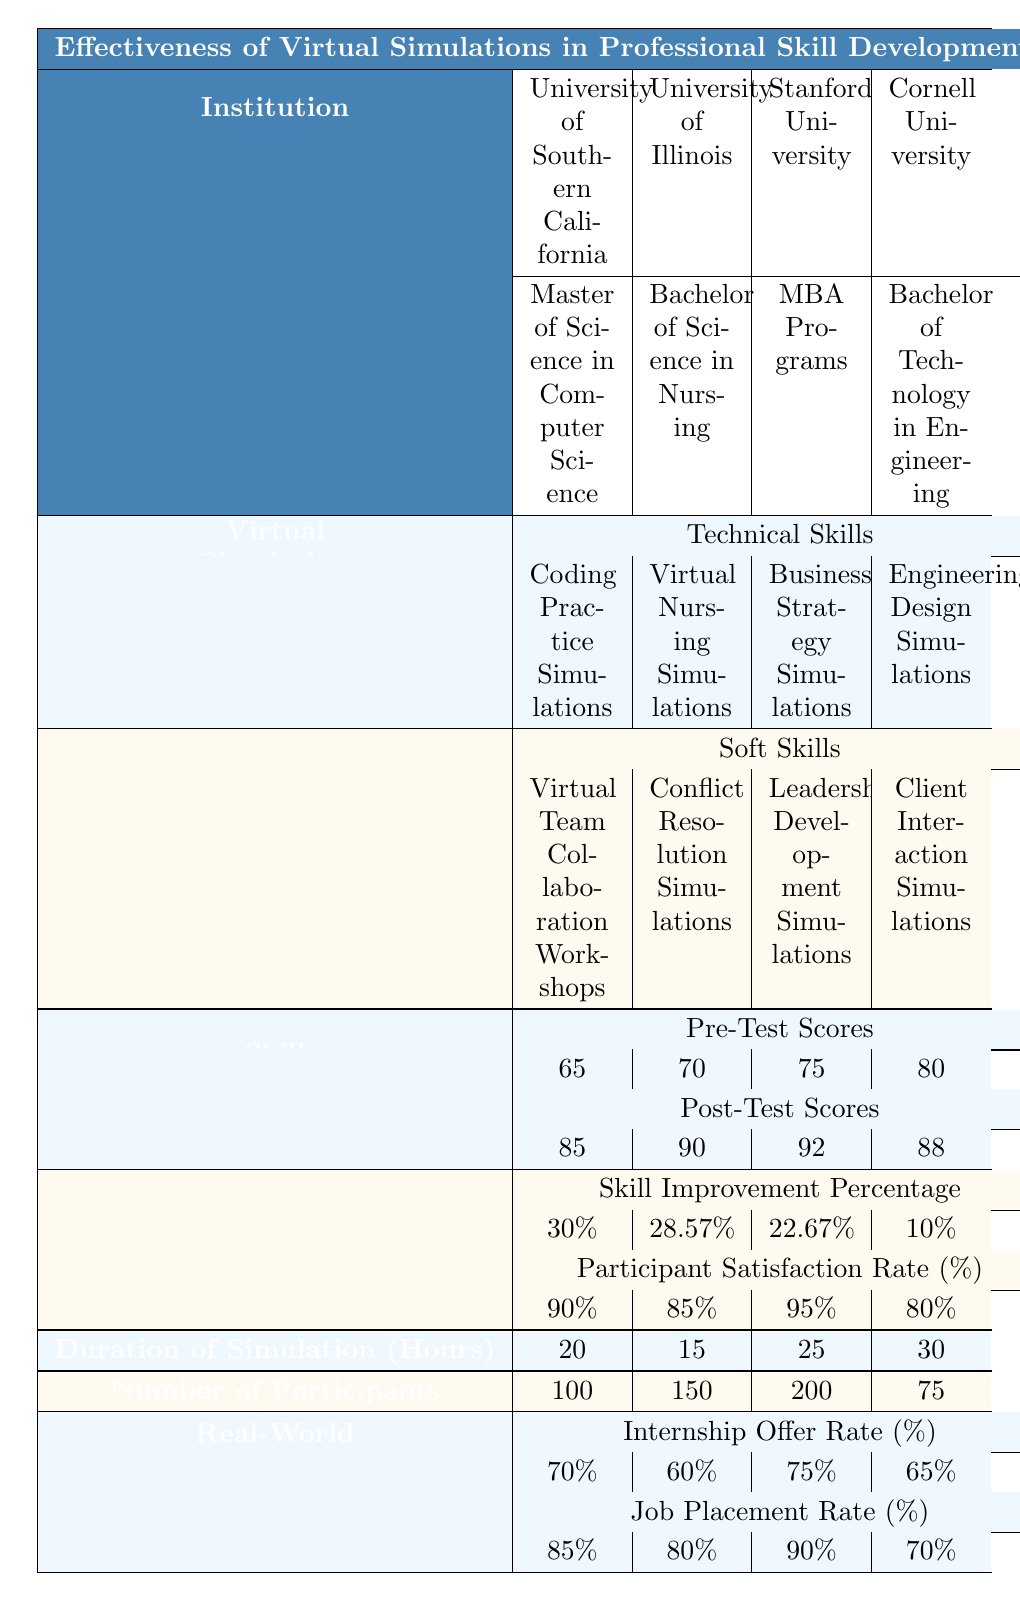What is the highest Post-Test Score among the institutions? The table lists the Post-Test Scores for each institution: 85, 90, 92, and 88. The highest score is 92 from Stanford University.
Answer: 92 Which institution had the lowest Participant Satisfaction Rate? The Participant Satisfaction Rates are 90%, 85%, 95%, and 80%. The lowest rate is 80%, which is from Cornell University.
Answer: Cornell University What is the average Skill Improvement Percentage across all institutions? The Skill Improvement Percentages are 30%, 28.57%, 22.67%, and 10%. Adding these gives 91.24%, and dividing by 4 for the average results in 22.81%.
Answer: 22.81% Did University of Illinois achieve a higher Internship Offer Rate than University of Southern California? The Internship Offer Rates are 60% for University of Illinois and 70% for University of Southern California. Since 60% is less than 70%, the statement is false.
Answer: No Which type of simulation showed the highest Skill Improvement Percentage, technical or soft skills? The Skill Improvement Percentages for technical skills are 30%, 28.57%, 22.67%, and for soft skills are 10%, indicating that technical skills had the highest average improvement.
Answer: Technical Skills What is the total number of participants across all institutions? Summing the Number of Participants gives 100 + 150 + 200 + 75 = 525.
Answer: 525 Which institution had the highest Job Placement Rate and what was the percentage? The Job Placement Rates are 85%, 80%, 90%, and 70%. The highest rate is 90%, which belongs to Stanford University.
Answer: 90% Is there a correlation between the Duration of Simulation and the Skill Improvement Percentage? Reviewing the Duration of Simulation and corresponding Skill Improvement Percentages shows no clear trend, as durations vary from 15 to 30 hours without a consistent improvement pattern. Further statistical analysis would be necessary to determine correlation.
Answer: No clear correlation What is the difference in Job Placement Rates between Stanford University and Cornell University? The Job Placement Rates are 90% for Stanford and 70% for Cornell. The difference is calculated as 90% - 70% = 20%.
Answer: 20% Which institution has the longest Duration of Simulation? The table shows the durations for each institution: 20, 15, 25, and 30 hours. The longest duration is 30 hours, which is for Cornell University.
Answer: Cornell University 